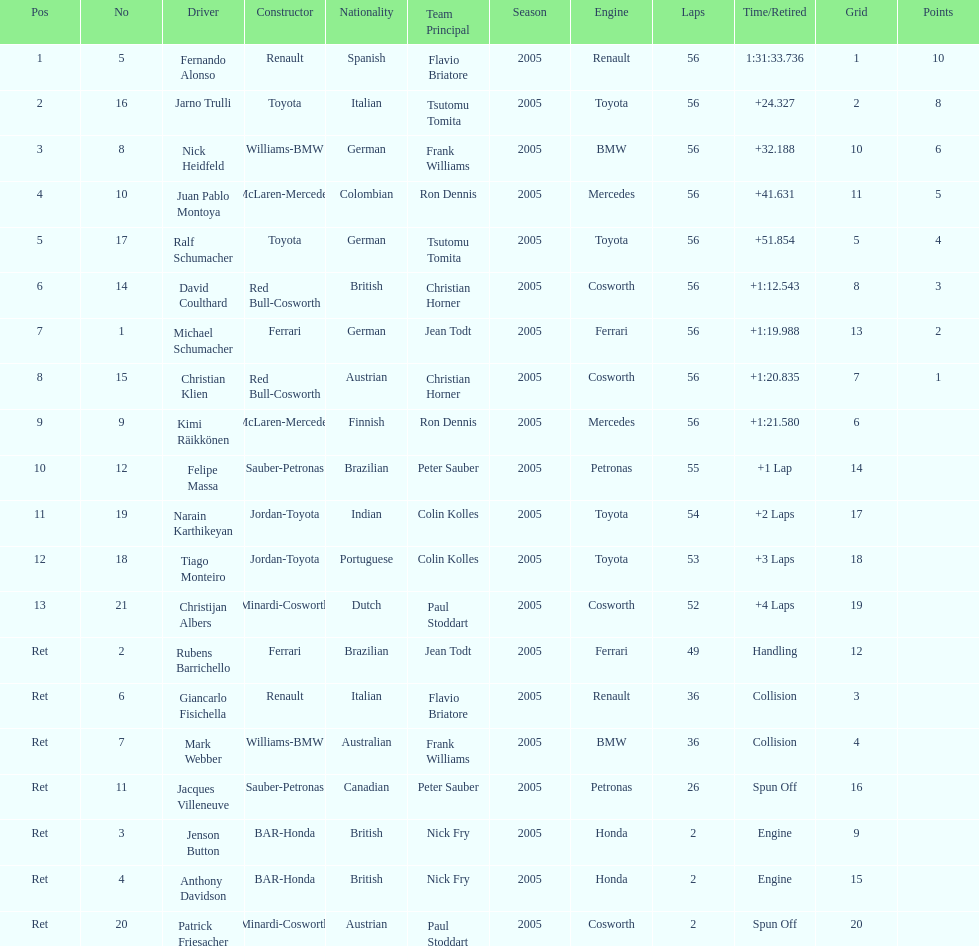How long did it take fernando alonso to finish the race? 1:31:33.736. 